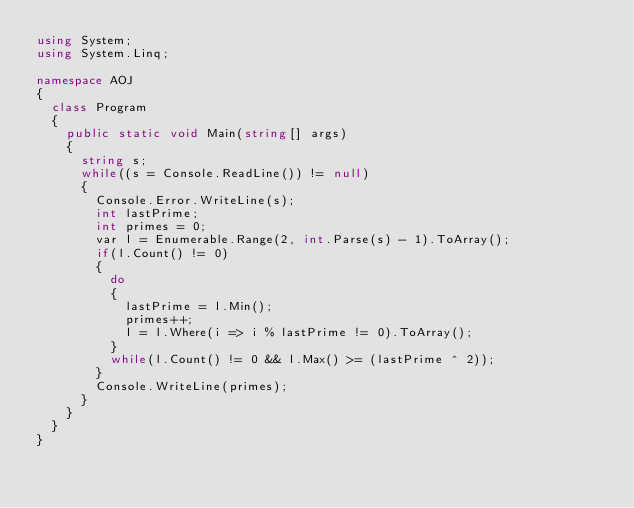<code> <loc_0><loc_0><loc_500><loc_500><_C#_>using System;
using System.Linq;

namespace AOJ
{
	class Program
	{
		public static void Main(string[] args)
		{
			string s;
			while((s = Console.ReadLine()) != null)
			{
				Console.Error.WriteLine(s);
				int lastPrime;
				int primes = 0;
				var l = Enumerable.Range(2, int.Parse(s) - 1).ToArray();
				if(l.Count() != 0)
				{
					do
					{
						lastPrime = l.Min();
						primes++;
						l = l.Where(i => i % lastPrime != 0).ToArray();
					}
					while(l.Count() != 0 && l.Max() >= (lastPrime ^ 2));
				}
				Console.WriteLine(primes);
			}
		}
	}
}</code> 